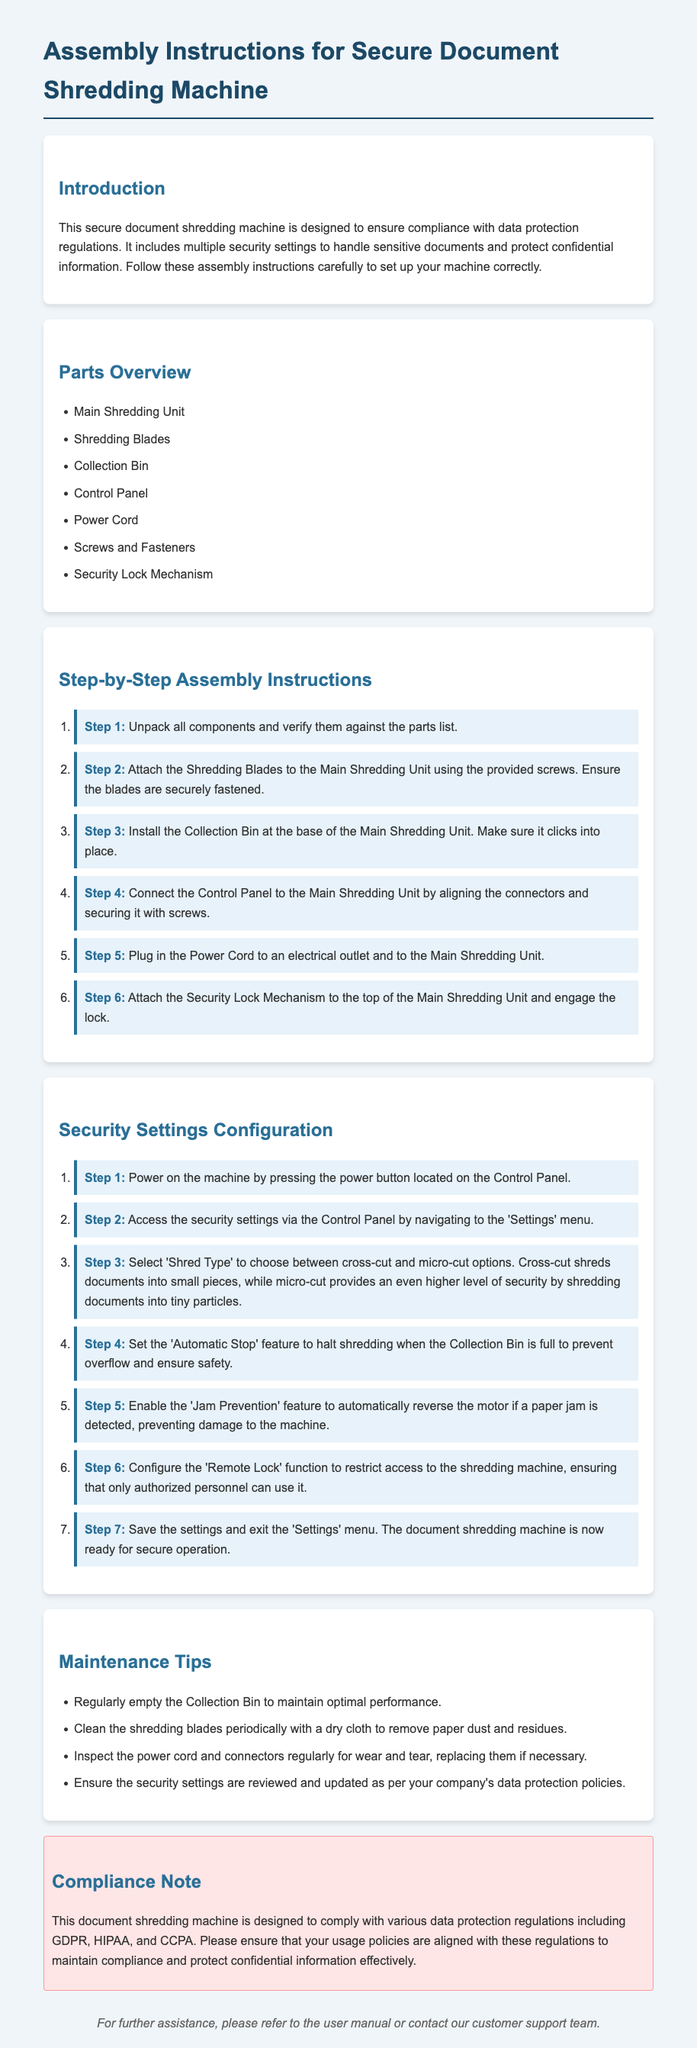what is the title of the document? The title of the document is found at the top of the rendered output which introduces the purpose and content of the document.
Answer: Assembly Instructions for Secure Document Shredding Machine how many main parts are listed in the Parts Overview section? The number of parts listed can be found in the bulleted list under the Parts Overview section of the document.
Answer: seven what is the first step of the assembly instructions? The first step of the assembly instructions is detailed in the ordered list under the Step-by-Step Assembly Instructions section.
Answer: Unpack all components and verify them against the parts list what feature prevents overflow when the Collection Bin is full? This feature is mentioned in the security settings configuration section of the document regarding the operation of the shredding machine.
Answer: Automatic Stop which shred type provides a higher level of security? The comparison of shred types provides information on which option is more secure in terms of document destruction.
Answer: micro-cut what should be done periodically to maintain the shredding blades? This maintenance tip details how often care should be taken with the shredding blades.
Answer: Clean which regulations does the machine comply with according to the compliance note? The compliance note section cites the specific regulations that the machine adheres to for data protection.
Answer: GDPR, HIPAA, CCPA what is the purpose of the Remote Lock function? The purpose is described in the security settings section, elaborating on the function's role in access control to the machine.
Answer: Restrict access to the shredding machine how can users ensure their usage policies are aligned with regulations? This is inferred from the final remarks in the compliance note, which highlights a critical aspect of maintaining compliance.
Answer: Review and update security settings 